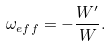Convert formula to latex. <formula><loc_0><loc_0><loc_500><loc_500>\omega _ { e f f } = - \frac { W ^ { \prime } } { W } .</formula> 